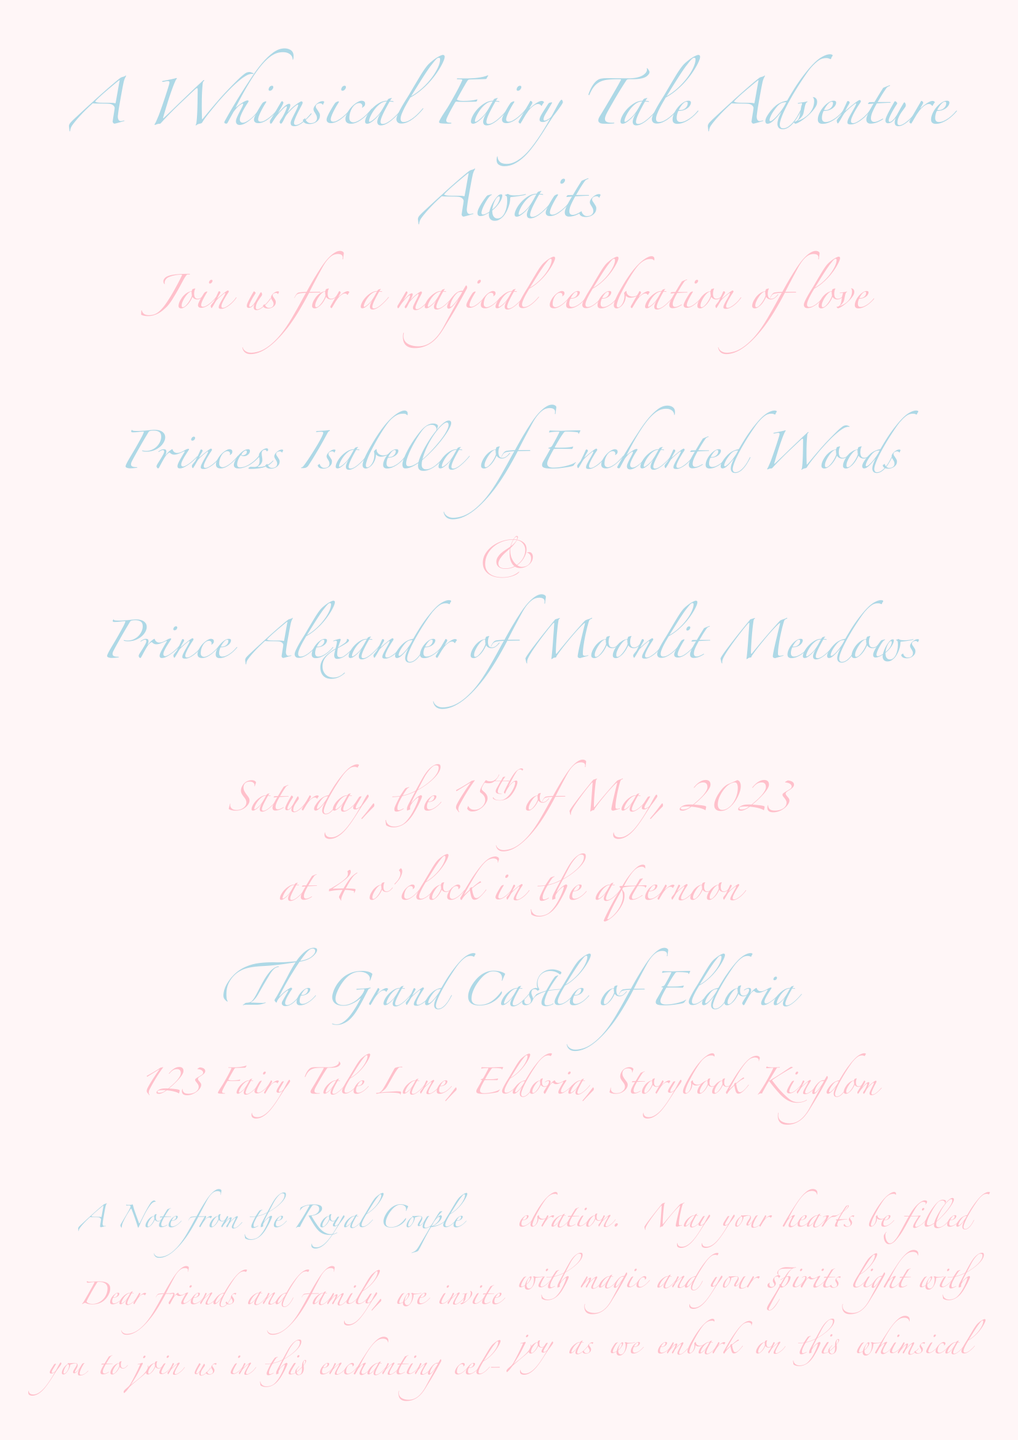What is the title of the event? The title is prominently displayed at the beginning of the invitation, indicating the theme of the celebration.
Answer: A Whimsical Fairy Tale Adventure Awaits Who are the bride and groom? The names of the couple are directly stated in the document, highlighting their royal titles.
Answer: Princess Isabella of Enchanted Woods & Prince Alexander of Moonlit Meadows What is the date of the wedding? The document specifies the date of the event in a clear format.
Answer: Saturday, the 15th of May, 2023 What is the location of the wedding? The venue is provided along with its name and address, making it easy to identify.
Answer: The Grand Castle of Eldoria, 123 Fairy Tale Lane, Eldoria, Storybook Kingdom What is the RSVP deadline? The invitation includes a deadline for responding to the invitation, which is important for planning.
Answer: 1st of May, 2023 What is the dress code? The document specifies a particular attire that guests are encouraged to wear, creating an enchanting atmosphere.
Answer: Fairy Tale Fantasy Attire What will the ceremony be blessed by? The document mentions a specific blessing, adding a magical element to the event.
Answer: The Fairy Queen What kind of celebration will follow the ceremony? It describes the events that will take place after the vows, indicating a festive atmosphere.
Answer: Royal Feast and Festivities 